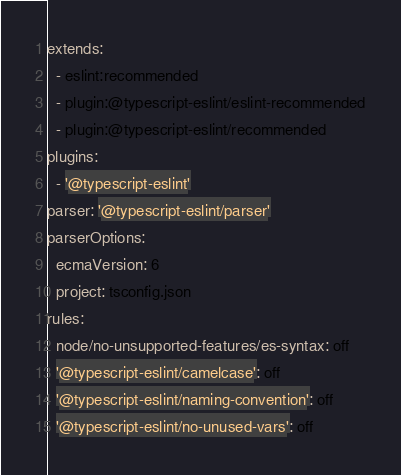<code> <loc_0><loc_0><loc_500><loc_500><_YAML_>extends:
  - eslint:recommended
  - plugin:@typescript-eslint/eslint-recommended
  - plugin:@typescript-eslint/recommended
plugins:
  - '@typescript-eslint'
parser: '@typescript-eslint/parser'
parserOptions:
  ecmaVersion: 6
  project: tsconfig.json
rules:
  node/no-unsupported-features/es-syntax: off
  '@typescript-eslint/camelcase': off
  '@typescript-eslint/naming-convention': off
  '@typescript-eslint/no-unused-vars': off
</code> 